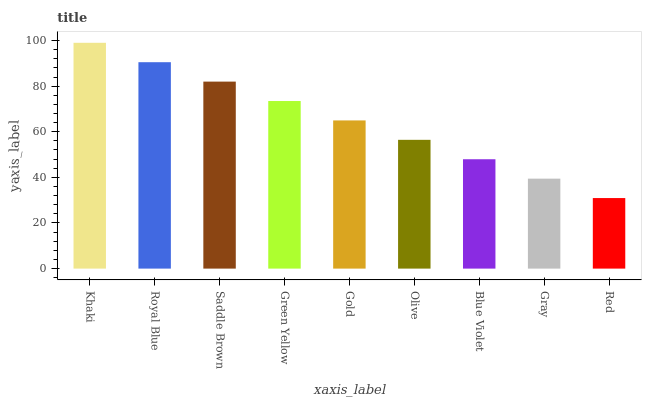Is Red the minimum?
Answer yes or no. Yes. Is Khaki the maximum?
Answer yes or no. Yes. Is Royal Blue the minimum?
Answer yes or no. No. Is Royal Blue the maximum?
Answer yes or no. No. Is Khaki greater than Royal Blue?
Answer yes or no. Yes. Is Royal Blue less than Khaki?
Answer yes or no. Yes. Is Royal Blue greater than Khaki?
Answer yes or no. No. Is Khaki less than Royal Blue?
Answer yes or no. No. Is Gold the high median?
Answer yes or no. Yes. Is Gold the low median?
Answer yes or no. Yes. Is Green Yellow the high median?
Answer yes or no. No. Is Green Yellow the low median?
Answer yes or no. No. 